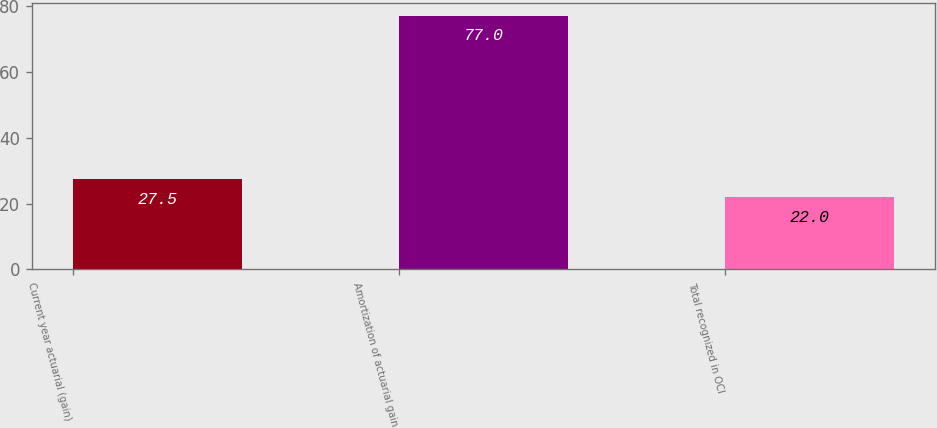Convert chart. <chart><loc_0><loc_0><loc_500><loc_500><bar_chart><fcel>Current year actuarial (gain)<fcel>Amortization of actuarial gain<fcel>Total recognized in OCI<nl><fcel>27.5<fcel>77<fcel>22<nl></chart> 